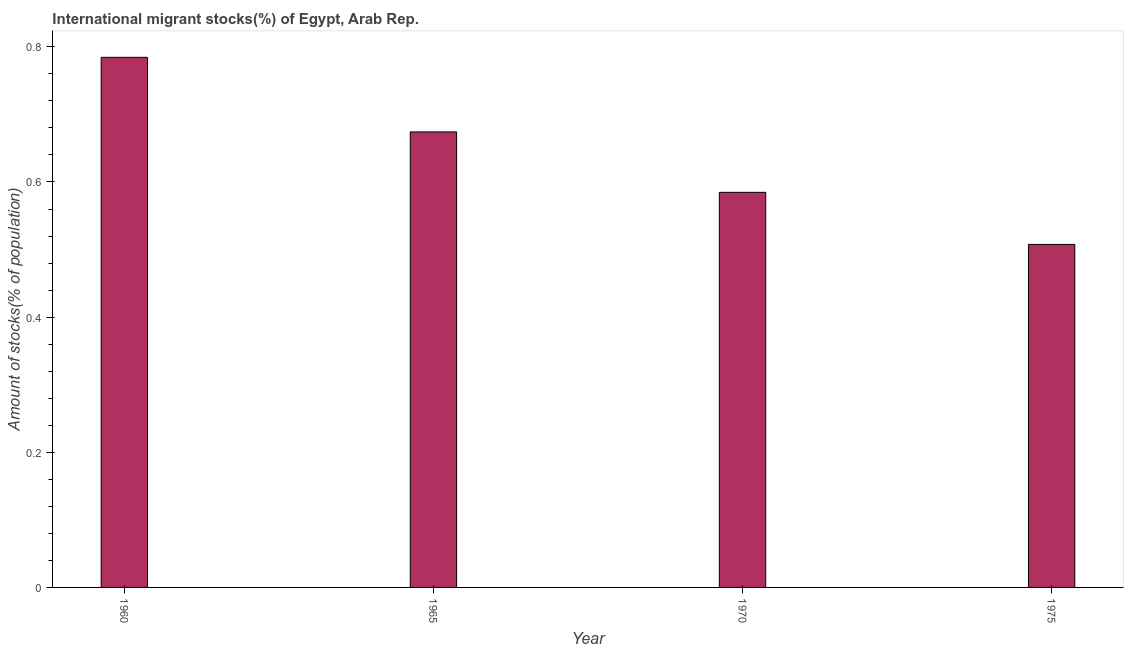Does the graph contain any zero values?
Your answer should be compact. No. What is the title of the graph?
Ensure brevity in your answer.  International migrant stocks(%) of Egypt, Arab Rep. What is the label or title of the X-axis?
Your response must be concise. Year. What is the label or title of the Y-axis?
Ensure brevity in your answer.  Amount of stocks(% of population). What is the number of international migrant stocks in 1975?
Offer a terse response. 0.51. Across all years, what is the maximum number of international migrant stocks?
Your response must be concise. 0.78. Across all years, what is the minimum number of international migrant stocks?
Keep it short and to the point. 0.51. In which year was the number of international migrant stocks minimum?
Give a very brief answer. 1975. What is the sum of the number of international migrant stocks?
Provide a short and direct response. 2.55. What is the difference between the number of international migrant stocks in 1965 and 1970?
Provide a succinct answer. 0.09. What is the average number of international migrant stocks per year?
Provide a short and direct response. 0.64. What is the median number of international migrant stocks?
Your response must be concise. 0.63. What is the ratio of the number of international migrant stocks in 1960 to that in 1970?
Offer a terse response. 1.34. Is the number of international migrant stocks in 1965 less than that in 1970?
Ensure brevity in your answer.  No. Is the difference between the number of international migrant stocks in 1965 and 1970 greater than the difference between any two years?
Keep it short and to the point. No. What is the difference between the highest and the second highest number of international migrant stocks?
Ensure brevity in your answer.  0.11. What is the difference between the highest and the lowest number of international migrant stocks?
Provide a short and direct response. 0.28. In how many years, is the number of international migrant stocks greater than the average number of international migrant stocks taken over all years?
Provide a short and direct response. 2. How many bars are there?
Your response must be concise. 4. Are all the bars in the graph horizontal?
Offer a terse response. No. How many years are there in the graph?
Provide a short and direct response. 4. What is the Amount of stocks(% of population) of 1960?
Your response must be concise. 0.78. What is the Amount of stocks(% of population) in 1965?
Make the answer very short. 0.67. What is the Amount of stocks(% of population) in 1970?
Provide a succinct answer. 0.58. What is the Amount of stocks(% of population) in 1975?
Provide a short and direct response. 0.51. What is the difference between the Amount of stocks(% of population) in 1960 and 1965?
Your answer should be very brief. 0.11. What is the difference between the Amount of stocks(% of population) in 1960 and 1970?
Your answer should be very brief. 0.2. What is the difference between the Amount of stocks(% of population) in 1960 and 1975?
Give a very brief answer. 0.28. What is the difference between the Amount of stocks(% of population) in 1965 and 1970?
Give a very brief answer. 0.09. What is the difference between the Amount of stocks(% of population) in 1965 and 1975?
Offer a terse response. 0.17. What is the difference between the Amount of stocks(% of population) in 1970 and 1975?
Provide a short and direct response. 0.08. What is the ratio of the Amount of stocks(% of population) in 1960 to that in 1965?
Your response must be concise. 1.16. What is the ratio of the Amount of stocks(% of population) in 1960 to that in 1970?
Provide a succinct answer. 1.34. What is the ratio of the Amount of stocks(% of population) in 1960 to that in 1975?
Provide a succinct answer. 1.54. What is the ratio of the Amount of stocks(% of population) in 1965 to that in 1970?
Provide a succinct answer. 1.15. What is the ratio of the Amount of stocks(% of population) in 1965 to that in 1975?
Give a very brief answer. 1.33. What is the ratio of the Amount of stocks(% of population) in 1970 to that in 1975?
Make the answer very short. 1.15. 